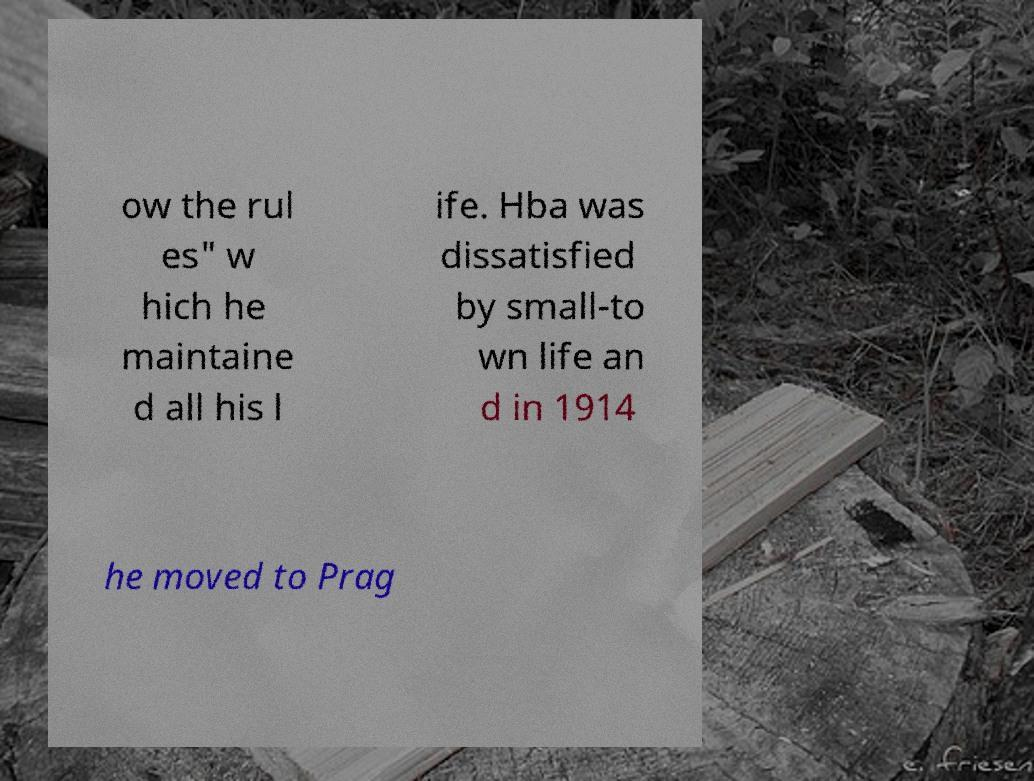I need the written content from this picture converted into text. Can you do that? ow the rul es" w hich he maintaine d all his l ife. Hba was dissatisfied by small-to wn life an d in 1914 he moved to Prag 